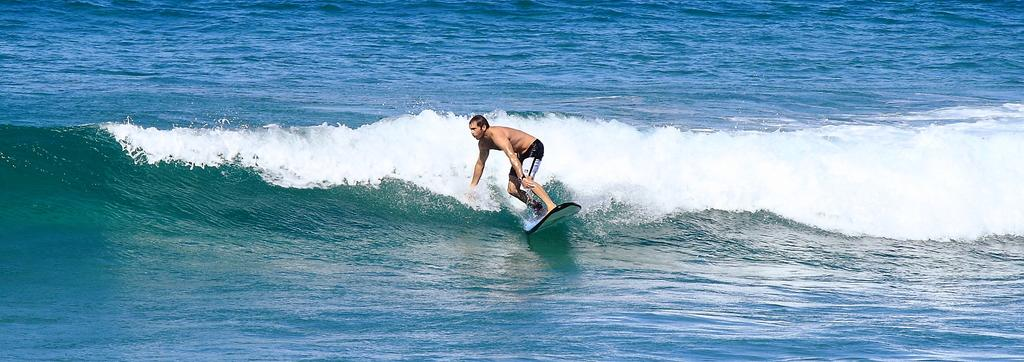What is happening in the image? There is a person in the image, and they are surfing on the water. Can you describe the person's activity in more detail? The person is standing on a surfboard and riding the waves on the water. What type of minister is depicted in the image? There is no minister present in the image; it features a person surfing on the water. What sound does the person make while surfing, and can you see a whistle in the image? There is no indication of any sound or whistle in the image; it only shows a person surfing on the water. 